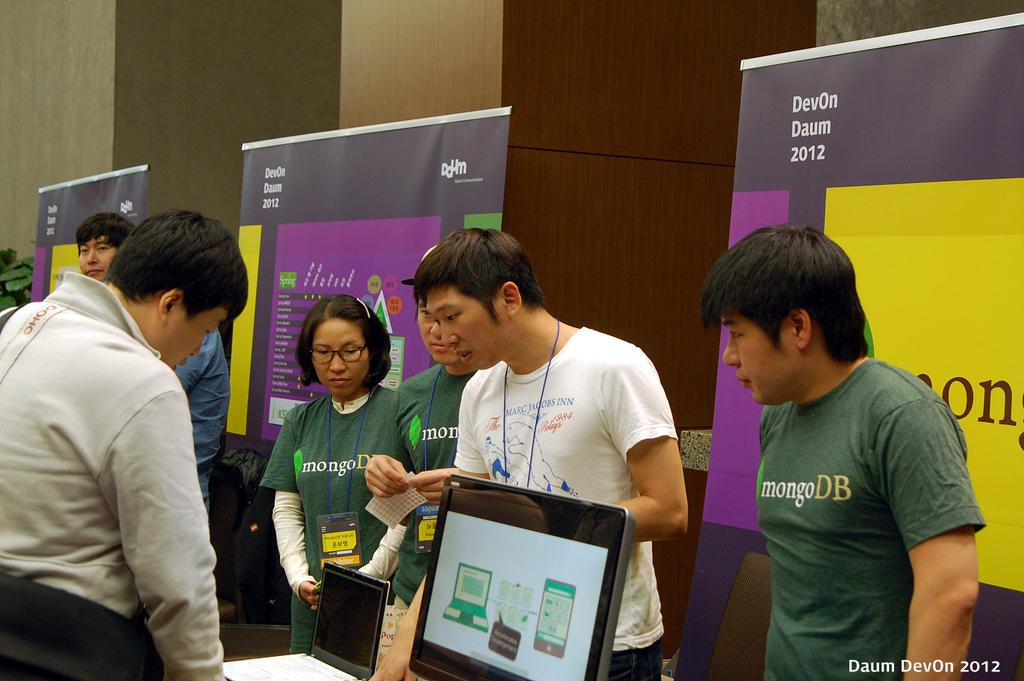What can be seen in the image? There are persons standing in the image, along with a monitor, a laptop, hoardings, a wall, and a plant on the left side. What electronic devices are present in the image? There is a monitor and a laptop in the image. What is visible in the background of the image? There are hoardings and a wall in the background of the image. Where is the plant located in the image? The plant is on the left side of the image. What type of advice can be seen written on the hoardings in the image? There is no advice visible on the hoardings in the image; they are likely advertising or displaying information. Can you describe the wilderness area visible in the image? There is no wilderness area present in the image; it features a more urban setting with electronic devices and hoardings. 